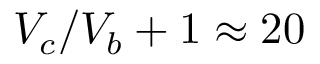Convert formula to latex. <formula><loc_0><loc_0><loc_500><loc_500>V _ { c } / V _ { b } + 1 \approx 2 0</formula> 